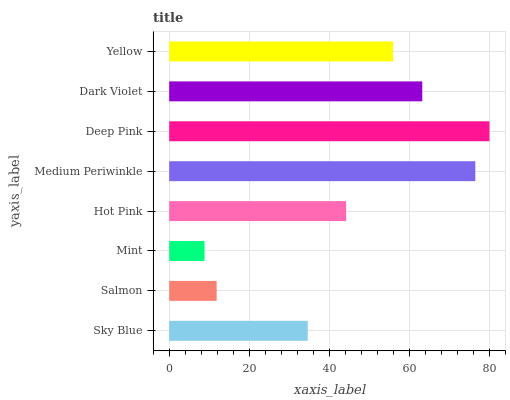Is Mint the minimum?
Answer yes or no. Yes. Is Deep Pink the maximum?
Answer yes or no. Yes. Is Salmon the minimum?
Answer yes or no. No. Is Salmon the maximum?
Answer yes or no. No. Is Sky Blue greater than Salmon?
Answer yes or no. Yes. Is Salmon less than Sky Blue?
Answer yes or no. Yes. Is Salmon greater than Sky Blue?
Answer yes or no. No. Is Sky Blue less than Salmon?
Answer yes or no. No. Is Yellow the high median?
Answer yes or no. Yes. Is Hot Pink the low median?
Answer yes or no. Yes. Is Medium Periwinkle the high median?
Answer yes or no. No. Is Deep Pink the low median?
Answer yes or no. No. 